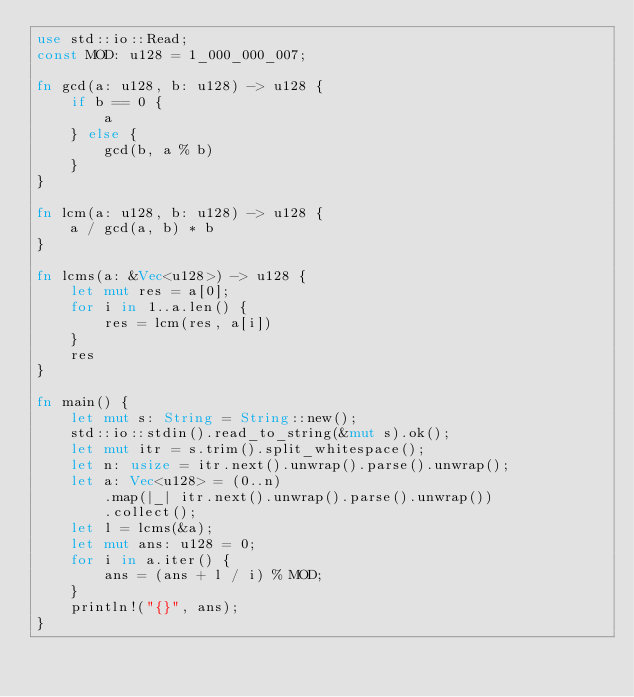Convert code to text. <code><loc_0><loc_0><loc_500><loc_500><_Rust_>use std::io::Read;
const MOD: u128 = 1_000_000_007;

fn gcd(a: u128, b: u128) -> u128 {
    if b == 0 {
        a
    } else {
        gcd(b, a % b)
    }
}

fn lcm(a: u128, b: u128) -> u128 {
    a / gcd(a, b) * b
}

fn lcms(a: &Vec<u128>) -> u128 {
    let mut res = a[0];
    for i in 1..a.len() {
        res = lcm(res, a[i])
    }
    res
}

fn main() {
    let mut s: String = String::new();
    std::io::stdin().read_to_string(&mut s).ok();
    let mut itr = s.trim().split_whitespace();
    let n: usize = itr.next().unwrap().parse().unwrap();
    let a: Vec<u128> = (0..n)
        .map(|_| itr.next().unwrap().parse().unwrap())
        .collect();
    let l = lcms(&a);
    let mut ans: u128 = 0;
    for i in a.iter() {
        ans = (ans + l / i) % MOD;
    }
    println!("{}", ans);
}
</code> 